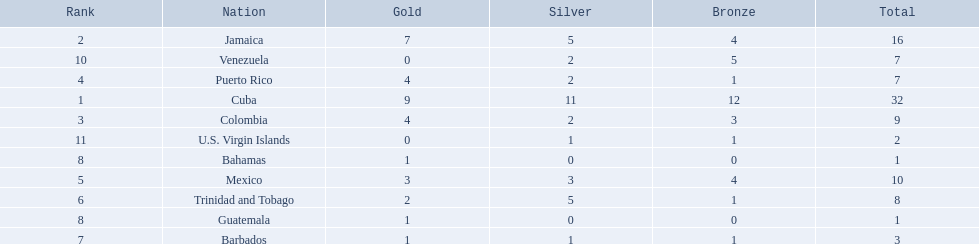Which 3 countries were awarded the most medals? Cuba, Jamaica, Colombia. Of these 3 countries which ones are islands? Cuba, Jamaica. Which one won the most silver medals? Cuba. 